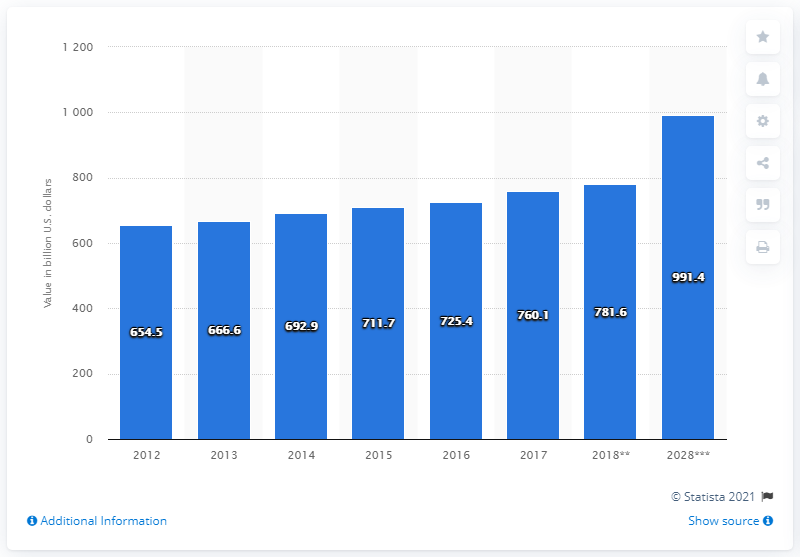Draw attention to some important aspects in this diagram. In 2017, the direct contribution of the travel and tourism industry to GDP in Europe was 760.1. 